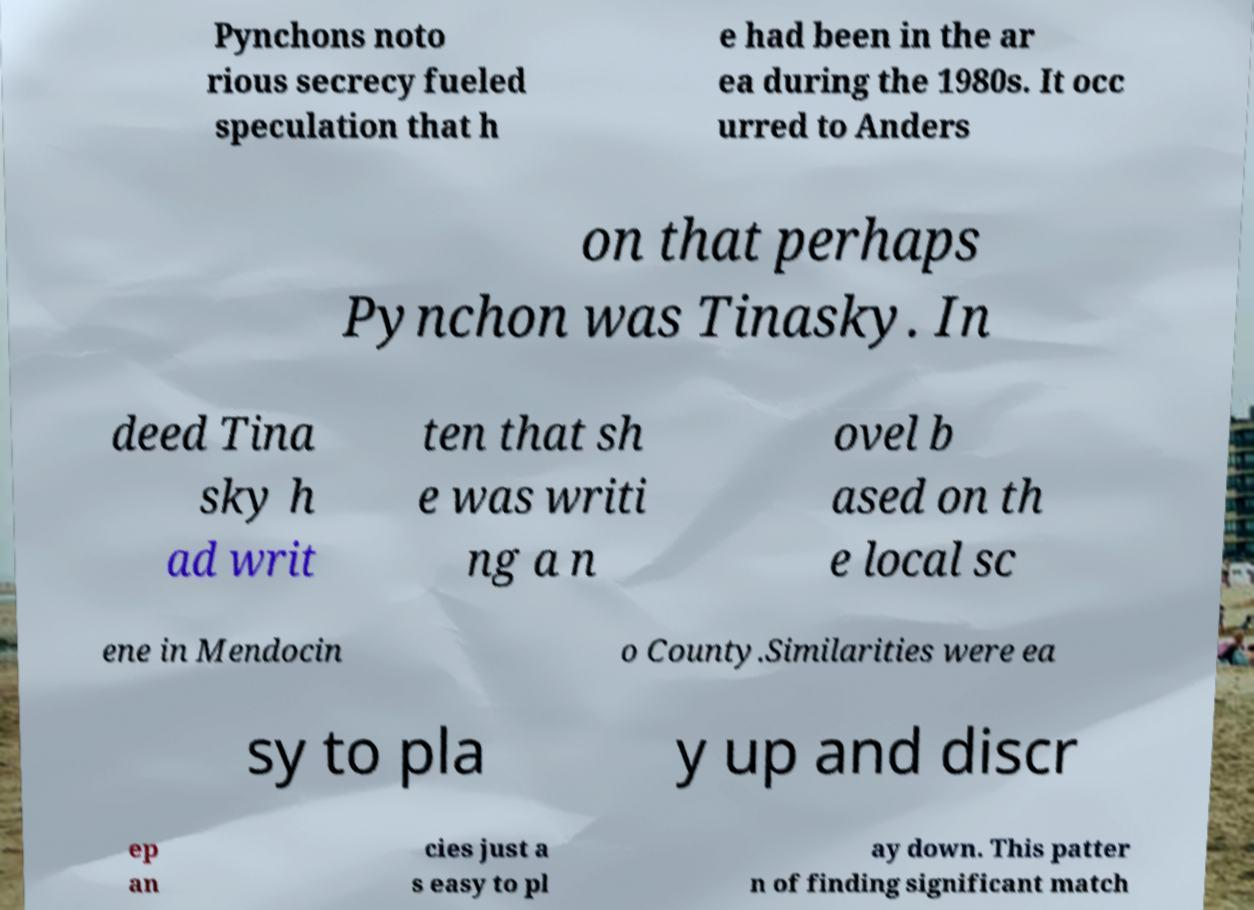Could you extract and type out the text from this image? Pynchons noto rious secrecy fueled speculation that h e had been in the ar ea during the 1980s. It occ urred to Anders on that perhaps Pynchon was Tinasky. In deed Tina sky h ad writ ten that sh e was writi ng a n ovel b ased on th e local sc ene in Mendocin o County.Similarities were ea sy to pla y up and discr ep an cies just a s easy to pl ay down. This patter n of finding significant match 